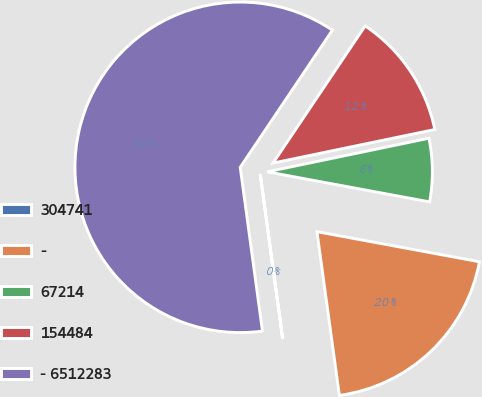Convert chart to OTSL. <chart><loc_0><loc_0><loc_500><loc_500><pie_chart><fcel>304741<fcel>-<fcel>67214<fcel>154484<fcel>- 6512283<nl><fcel>0.02%<fcel>19.92%<fcel>6.17%<fcel>12.33%<fcel>61.57%<nl></chart> 